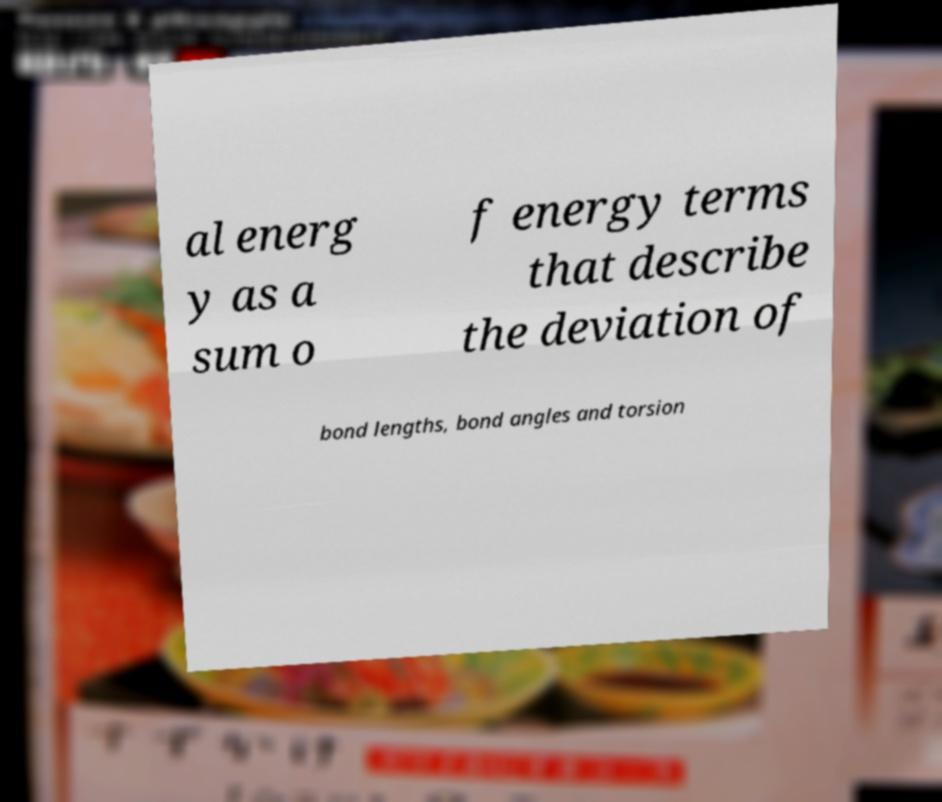Can you accurately transcribe the text from the provided image for me? al energ y as a sum o f energy terms that describe the deviation of bond lengths, bond angles and torsion 